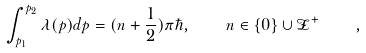<formula> <loc_0><loc_0><loc_500><loc_500>\int _ { p _ { 1 } } ^ { p _ { 2 } } \lambda ( p ) d p = ( n + \frac { 1 } { 2 } ) \pi \hbar { , } \quad n \in \{ 0 \} \cup \mathcal { Z } ^ { + } \quad ,</formula> 